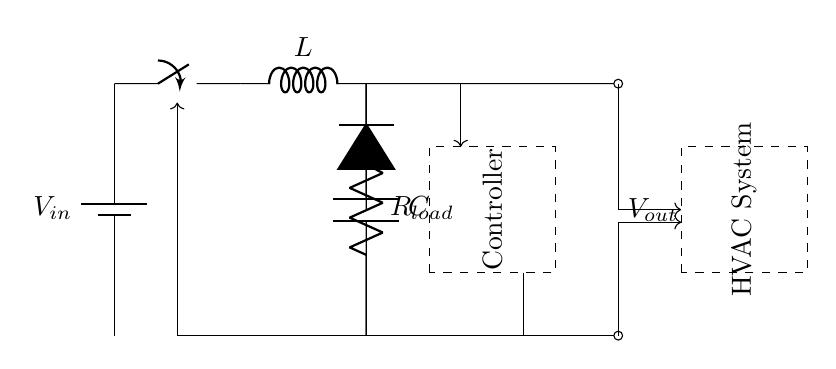What is the input voltage in the circuit? The input voltage is denoted by the symbol Vin, which can typically be found at the battery component in the circuit.
Answer: Vin What component is used to store energy in the circuit? The inductor, labeled as L in the diagram, is the component responsible for storing energy in the circuit during the switching process.
Answer: L What is the function of the diode in this circuit? The diode allows current to flow in one direction, preventing reverse current that could damage the circuit or disrupt functionality. It is essential for rectifying the AC to DC component.
Answer: Rectification How does the controller influence the output voltage? The controller compares the output voltage Vout to a reference voltage and adjusts the operation of the switch, thereby influencing the energy delivered to the load and maintaining a stable output voltage.
Answer: Regulation What happens to the current when the switch is closed? When the switch is closed, current flows through the inductor and charging the capacitor, which results in energy being stored in the inductor and then released to the load when the switch opens.
Answer: Energy storage What type of regulator is represented in the circuit? The circuit depicts a switching regulator, which uses a switch to control the energy flow efficiently.
Answer: Switching regulator 